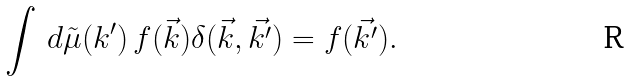<formula> <loc_0><loc_0><loc_500><loc_500>\int \, d \tilde { \mu } ( k ^ { \prime } ) \, f ( \vec { k } ) \delta ( \vec { k } , \vec { k ^ { \prime } } ) = f ( \vec { k ^ { \prime } } ) .</formula> 